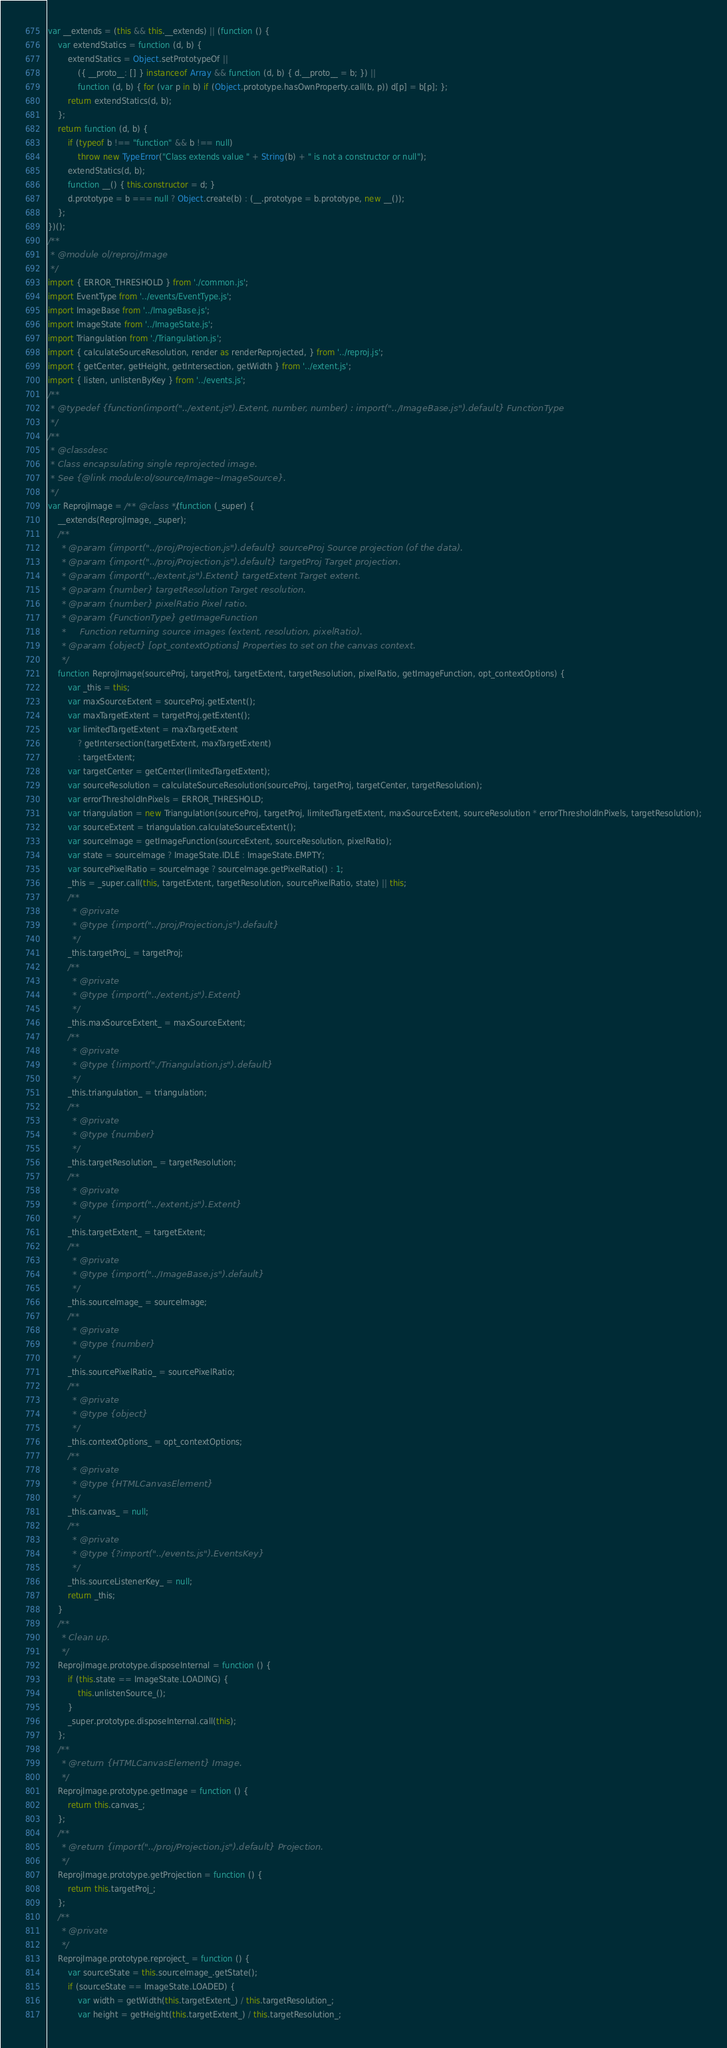<code> <loc_0><loc_0><loc_500><loc_500><_JavaScript_>var __extends = (this && this.__extends) || (function () {
    var extendStatics = function (d, b) {
        extendStatics = Object.setPrototypeOf ||
            ({ __proto__: [] } instanceof Array && function (d, b) { d.__proto__ = b; }) ||
            function (d, b) { for (var p in b) if (Object.prototype.hasOwnProperty.call(b, p)) d[p] = b[p]; };
        return extendStatics(d, b);
    };
    return function (d, b) {
        if (typeof b !== "function" && b !== null)
            throw new TypeError("Class extends value " + String(b) + " is not a constructor or null");
        extendStatics(d, b);
        function __() { this.constructor = d; }
        d.prototype = b === null ? Object.create(b) : (__.prototype = b.prototype, new __());
    };
})();
/**
 * @module ol/reproj/Image
 */
import { ERROR_THRESHOLD } from './common.js';
import EventType from '../events/EventType.js';
import ImageBase from '../ImageBase.js';
import ImageState from '../ImageState.js';
import Triangulation from './Triangulation.js';
import { calculateSourceResolution, render as renderReprojected, } from '../reproj.js';
import { getCenter, getHeight, getIntersection, getWidth } from '../extent.js';
import { listen, unlistenByKey } from '../events.js';
/**
 * @typedef {function(import("../extent.js").Extent, number, number) : import("../ImageBase.js").default} FunctionType
 */
/**
 * @classdesc
 * Class encapsulating single reprojected image.
 * See {@link module:ol/source/Image~ImageSource}.
 */
var ReprojImage = /** @class */ (function (_super) {
    __extends(ReprojImage, _super);
    /**
     * @param {import("../proj/Projection.js").default} sourceProj Source projection (of the data).
     * @param {import("../proj/Projection.js").default} targetProj Target projection.
     * @param {import("../extent.js").Extent} targetExtent Target extent.
     * @param {number} targetResolution Target resolution.
     * @param {number} pixelRatio Pixel ratio.
     * @param {FunctionType} getImageFunction
     *     Function returning source images (extent, resolution, pixelRatio).
     * @param {object} [opt_contextOptions] Properties to set on the canvas context.
     */
    function ReprojImage(sourceProj, targetProj, targetExtent, targetResolution, pixelRatio, getImageFunction, opt_contextOptions) {
        var _this = this;
        var maxSourceExtent = sourceProj.getExtent();
        var maxTargetExtent = targetProj.getExtent();
        var limitedTargetExtent = maxTargetExtent
            ? getIntersection(targetExtent, maxTargetExtent)
            : targetExtent;
        var targetCenter = getCenter(limitedTargetExtent);
        var sourceResolution = calculateSourceResolution(sourceProj, targetProj, targetCenter, targetResolution);
        var errorThresholdInPixels = ERROR_THRESHOLD;
        var triangulation = new Triangulation(sourceProj, targetProj, limitedTargetExtent, maxSourceExtent, sourceResolution * errorThresholdInPixels, targetResolution);
        var sourceExtent = triangulation.calculateSourceExtent();
        var sourceImage = getImageFunction(sourceExtent, sourceResolution, pixelRatio);
        var state = sourceImage ? ImageState.IDLE : ImageState.EMPTY;
        var sourcePixelRatio = sourceImage ? sourceImage.getPixelRatio() : 1;
        _this = _super.call(this, targetExtent, targetResolution, sourcePixelRatio, state) || this;
        /**
         * @private
         * @type {import("../proj/Projection.js").default}
         */
        _this.targetProj_ = targetProj;
        /**
         * @private
         * @type {import("../extent.js").Extent}
         */
        _this.maxSourceExtent_ = maxSourceExtent;
        /**
         * @private
         * @type {!import("./Triangulation.js").default}
         */
        _this.triangulation_ = triangulation;
        /**
         * @private
         * @type {number}
         */
        _this.targetResolution_ = targetResolution;
        /**
         * @private
         * @type {import("../extent.js").Extent}
         */
        _this.targetExtent_ = targetExtent;
        /**
         * @private
         * @type {import("../ImageBase.js").default}
         */
        _this.sourceImage_ = sourceImage;
        /**
         * @private
         * @type {number}
         */
        _this.sourcePixelRatio_ = sourcePixelRatio;
        /**
         * @private
         * @type {object}
         */
        _this.contextOptions_ = opt_contextOptions;
        /**
         * @private
         * @type {HTMLCanvasElement}
         */
        _this.canvas_ = null;
        /**
         * @private
         * @type {?import("../events.js").EventsKey}
         */
        _this.sourceListenerKey_ = null;
        return _this;
    }
    /**
     * Clean up.
     */
    ReprojImage.prototype.disposeInternal = function () {
        if (this.state == ImageState.LOADING) {
            this.unlistenSource_();
        }
        _super.prototype.disposeInternal.call(this);
    };
    /**
     * @return {HTMLCanvasElement} Image.
     */
    ReprojImage.prototype.getImage = function () {
        return this.canvas_;
    };
    /**
     * @return {import("../proj/Projection.js").default} Projection.
     */
    ReprojImage.prototype.getProjection = function () {
        return this.targetProj_;
    };
    /**
     * @private
     */
    ReprojImage.prototype.reproject_ = function () {
        var sourceState = this.sourceImage_.getState();
        if (sourceState == ImageState.LOADED) {
            var width = getWidth(this.targetExtent_) / this.targetResolution_;
            var height = getHeight(this.targetExtent_) / this.targetResolution_;</code> 